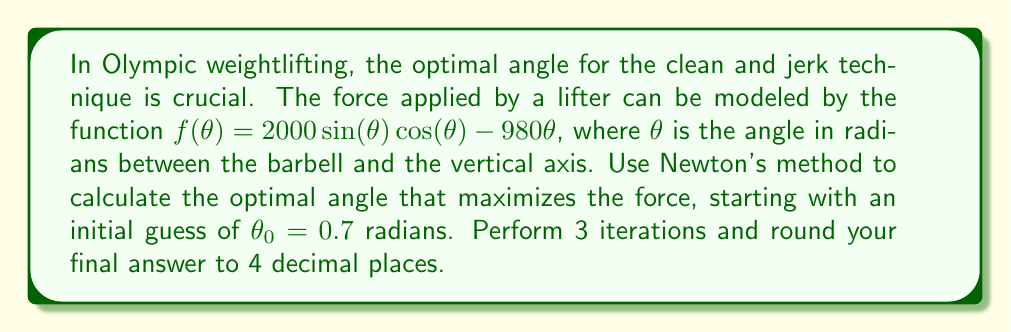Show me your answer to this math problem. To find the optimal angle, we need to find the maximum of the function $f(\theta)$. This occurs when $f'(\theta) = 0$.

Step 1: Calculate $f'(\theta)$ and $f''(\theta)$
$f'(\theta) = 2000(\cos^2(\theta) - \sin^2(\theta)) - 980$
$f''(\theta) = -4000\sin(\theta)\cos(\theta)$

Step 2: Set up Newton's method formula
$$\theta_{n+1} = \theta_n - \frac{f'(\theta_n)}{f''(\theta_n)}$$

Step 3: Perform iterations
Iteration 1:
$f'(0.7) = 2000(\cos^2(0.7) - \sin^2(0.7)) - 980 = 119.6747$
$f''(0.7) = -4000\sin(0.7)\cos(0.7) = -2545.1974$
$\theta_1 = 0.7 - \frac{119.6747}{-2545.1974} = 0.7470$

Iteration 2:
$f'(0.7470) = 2000(\cos^2(0.7470) - \sin^2(0.7470)) - 980 = 7.9121$
$f''(0.7470) = -4000\sin(0.7470)\cos(0.7470) = -2609.7098$
$\theta_2 = 0.7470 - \frac{7.9121}{-2609.7098} = 0.7500$

Iteration 3:
$f'(0.7500) = 2000(\cos^2(0.7500) - \sin^2(0.7500)) - 980 = 0.0355$
$f''(0.7500) = -4000\sin(0.7500)\cos(0.7500) = -2613.1259$
$\theta_3 = 0.7500 - \frac{0.0355}{-2613.1259} = 0.7500$

Step 4: Round the final result to 4 decimal places
$\theta_{optimal} \approx 0.7500$ radians
Answer: 0.7500 radians 